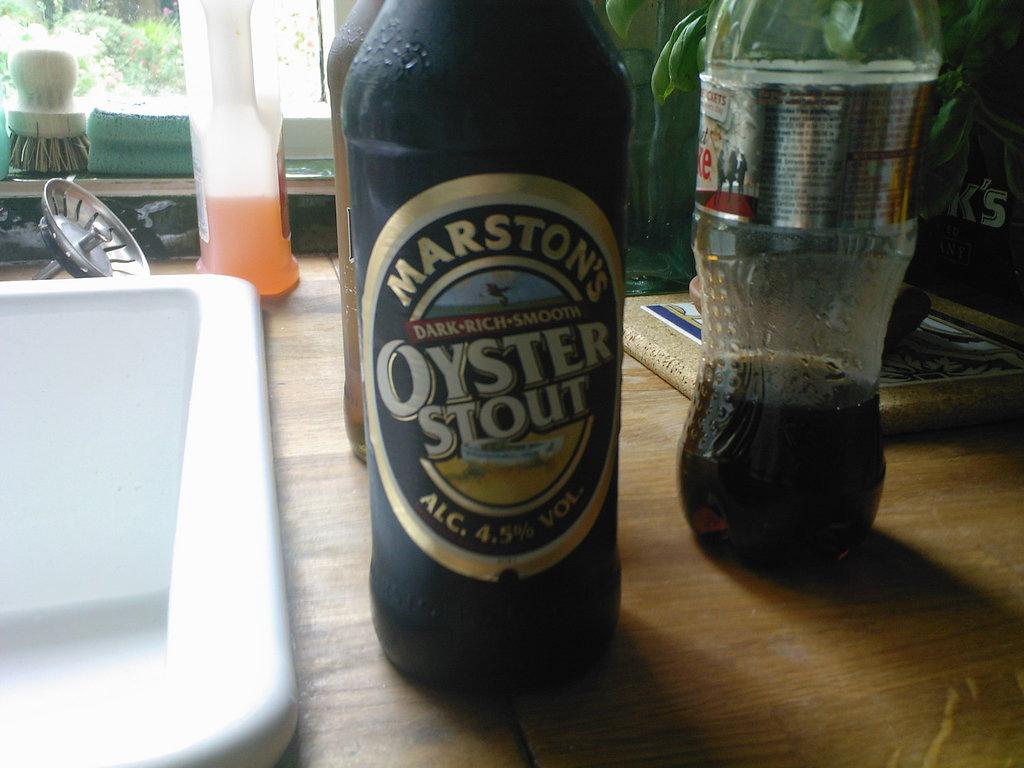What stout is that?
Make the answer very short. Oyster stout. What brand is the oyster stout?
Your response must be concise. Marston's. 